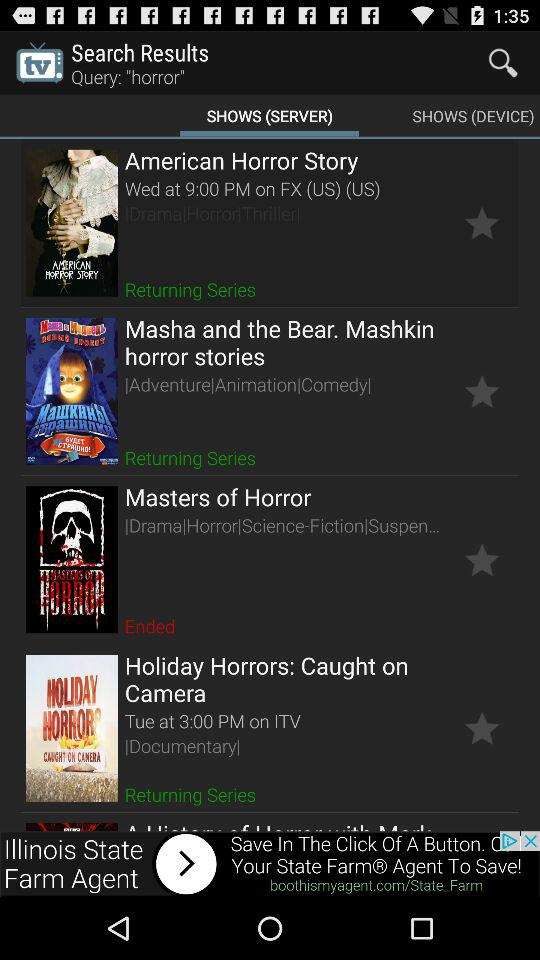Which tab is selected? The selected tab is "SHOWS (SERVER)". 